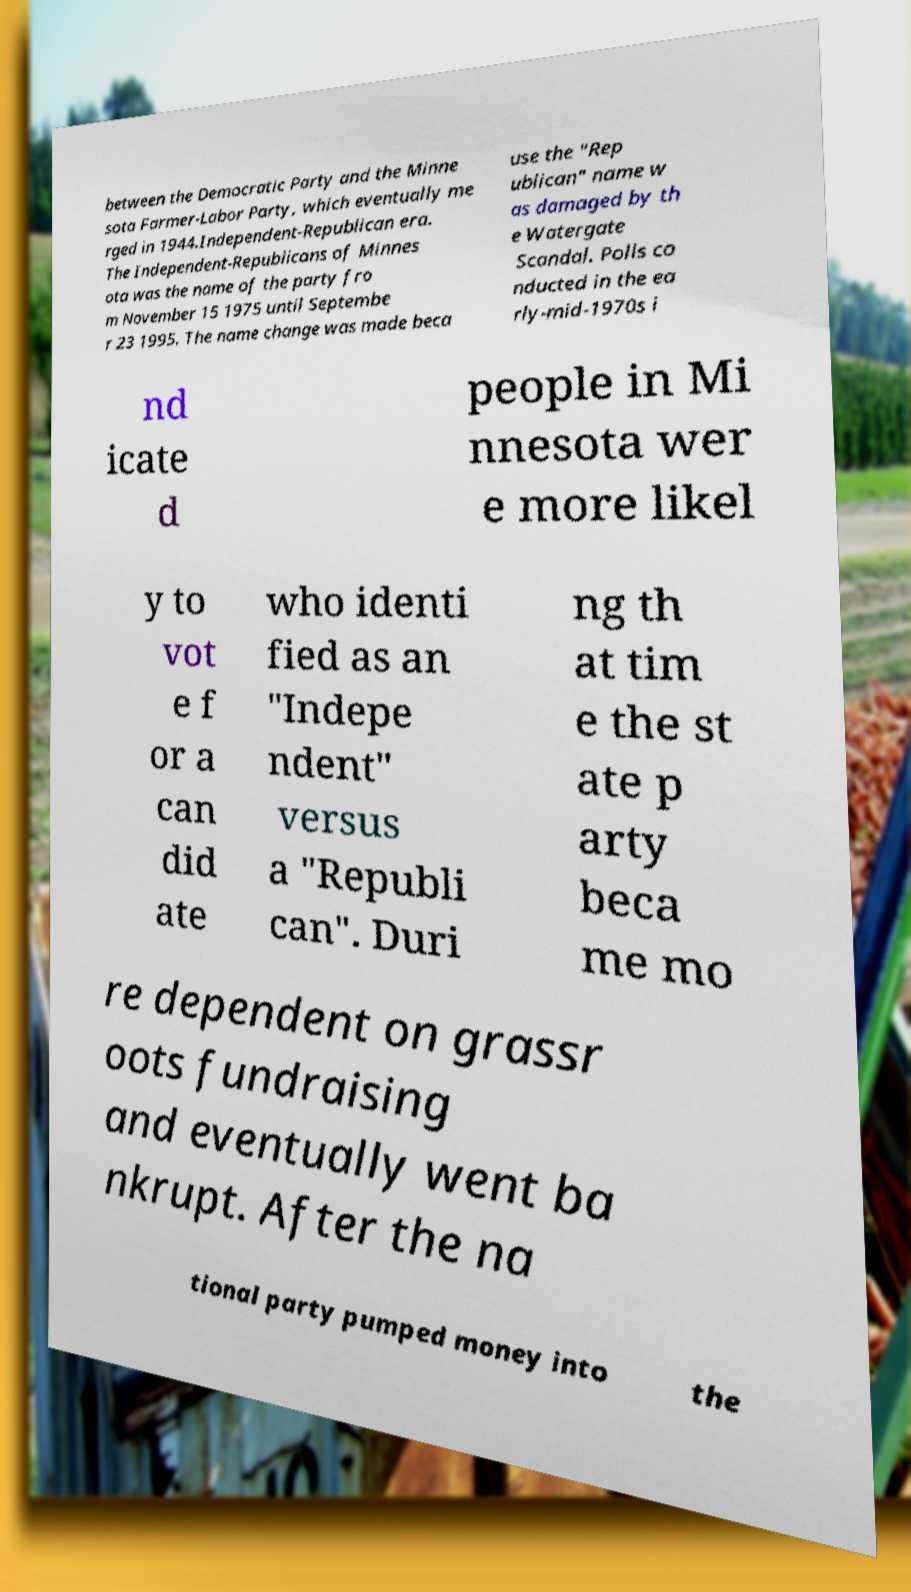Could you assist in decoding the text presented in this image and type it out clearly? between the Democratic Party and the Minne sota Farmer-Labor Party, which eventually me rged in 1944.Independent-Republican era. The Independent-Republicans of Minnes ota was the name of the party fro m November 15 1975 until Septembe r 23 1995. The name change was made beca use the "Rep ublican" name w as damaged by th e Watergate Scandal. Polls co nducted in the ea rly-mid-1970s i nd icate d people in Mi nnesota wer e more likel y to vot e f or a can did ate who identi fied as an "Indepe ndent" versus a "Republi can". Duri ng th at tim e the st ate p arty beca me mo re dependent on grassr oots fundraising and eventually went ba nkrupt. After the na tional party pumped money into the 